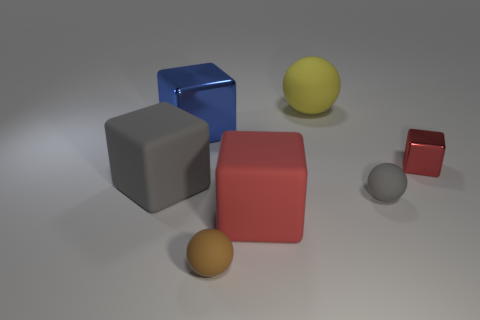How many yellow rubber spheres are there?
Offer a very short reply. 1. What is the material of the red cube that is behind the large matte cube that is right of the sphere that is to the left of the large red matte thing?
Your response must be concise. Metal. How many tiny gray balls are to the right of the red object behind the large red rubber cube?
Keep it short and to the point. 0. What color is the other rubber thing that is the same shape as the large red thing?
Give a very brief answer. Gray. Is the yellow thing made of the same material as the tiny gray object?
Offer a very short reply. Yes. How many balls are small red things or matte objects?
Keep it short and to the point. 3. What size is the block that is on the right side of the gray object that is right of the small ball that is on the left side of the large yellow matte sphere?
Keep it short and to the point. Small. The other metallic object that is the same shape as the small red thing is what size?
Offer a terse response. Large. How many matte blocks are on the right side of the blue shiny object?
Offer a very short reply. 1. Is the color of the big block to the right of the small brown rubber ball the same as the tiny metal block?
Keep it short and to the point. Yes. 